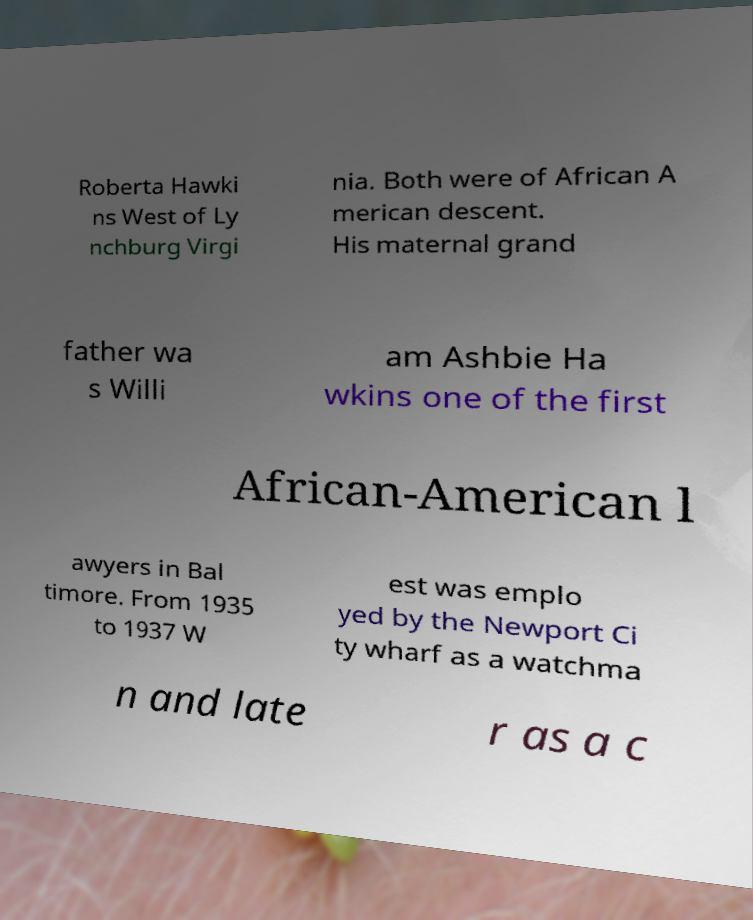Please read and relay the text visible in this image. What does it say? Roberta Hawki ns West of Ly nchburg Virgi nia. Both were of African A merican descent. His maternal grand father wa s Willi am Ashbie Ha wkins one of the first African-American l awyers in Bal timore. From 1935 to 1937 W est was emplo yed by the Newport Ci ty wharf as a watchma n and late r as a c 